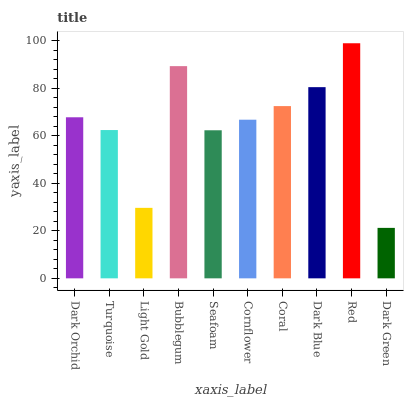Is Dark Green the minimum?
Answer yes or no. Yes. Is Red the maximum?
Answer yes or no. Yes. Is Turquoise the minimum?
Answer yes or no. No. Is Turquoise the maximum?
Answer yes or no. No. Is Dark Orchid greater than Turquoise?
Answer yes or no. Yes. Is Turquoise less than Dark Orchid?
Answer yes or no. Yes. Is Turquoise greater than Dark Orchid?
Answer yes or no. No. Is Dark Orchid less than Turquoise?
Answer yes or no. No. Is Dark Orchid the high median?
Answer yes or no. Yes. Is Cornflower the low median?
Answer yes or no. Yes. Is Bubblegum the high median?
Answer yes or no. No. Is Dark Orchid the low median?
Answer yes or no. No. 